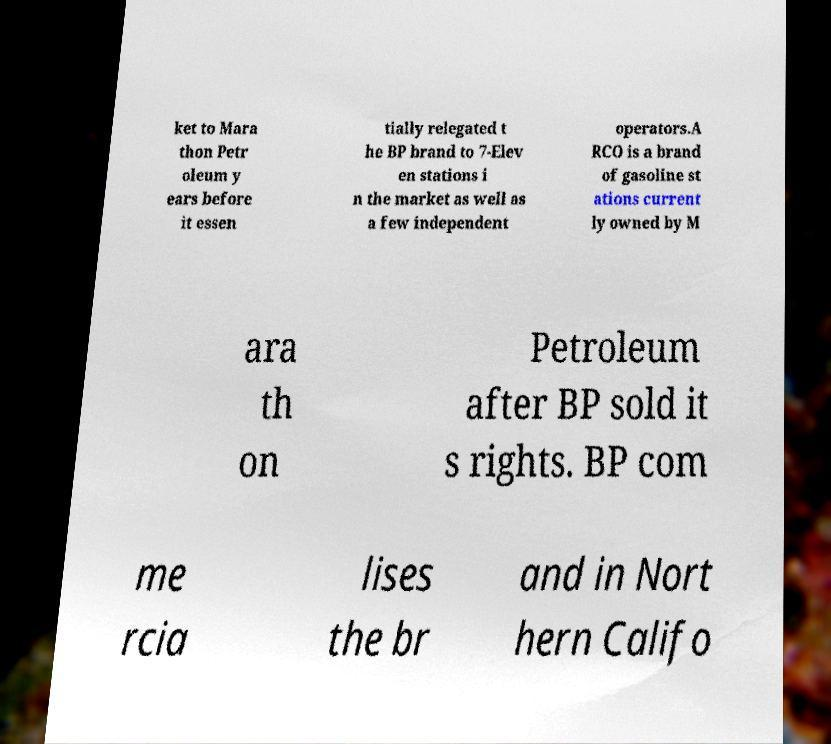What messages or text are displayed in this image? I need them in a readable, typed format. ket to Mara thon Petr oleum y ears before it essen tially relegated t he BP brand to 7-Elev en stations i n the market as well as a few independent operators.A RCO is a brand of gasoline st ations current ly owned by M ara th on Petroleum after BP sold it s rights. BP com me rcia lises the br and in Nort hern Califo 